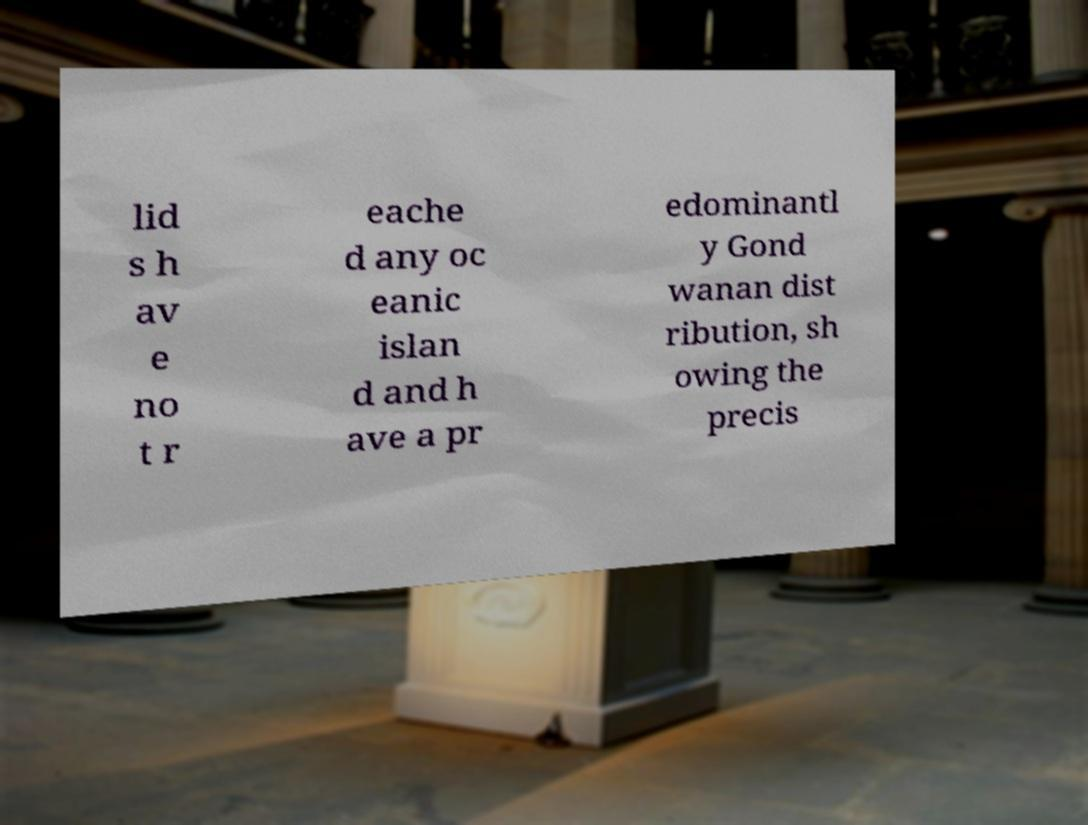Can you read and provide the text displayed in the image?This photo seems to have some interesting text. Can you extract and type it out for me? lid s h av e no t r eache d any oc eanic islan d and h ave a pr edominantl y Gond wanan dist ribution, sh owing the precis 